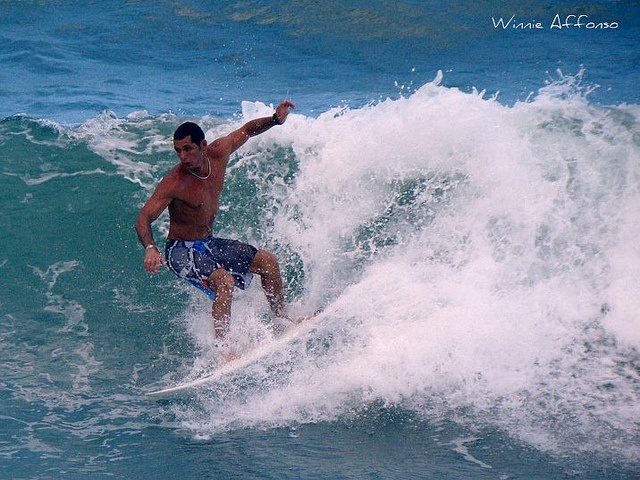Describe the objects in this image and their specific colors. I can see people in teal, maroon, black, gray, and navy tones and surfboard in teal, lavender, darkgray, gray, and lightgray tones in this image. 